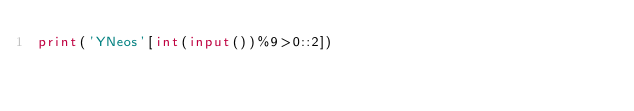<code> <loc_0><loc_0><loc_500><loc_500><_Python_>print('YNeos'[int(input())%9>0::2])</code> 